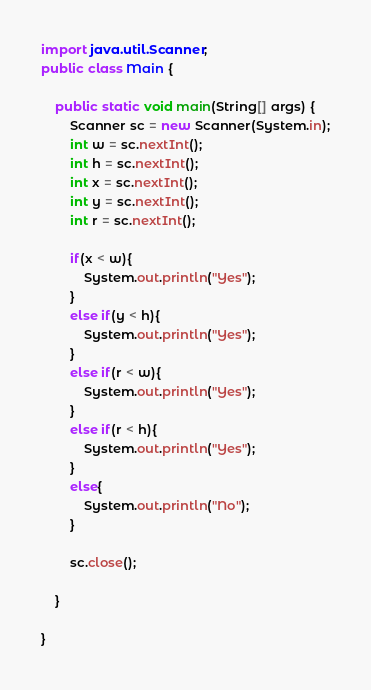<code> <loc_0><loc_0><loc_500><loc_500><_Java_>import java.util.Scanner;
public class Main {

	public static void main(String[] args) {
		Scanner sc = new Scanner(System.in);
		int w = sc.nextInt();
		int h = sc.nextInt();
		int x = sc.nextInt();
		int y = sc.nextInt();
		int r = sc.nextInt();

		if(x < w){
			System.out.println("Yes");
		}
		else if(y < h){
			System.out.println("Yes");
		}
		else if(r < w){
			System.out.println("Yes");
		}
		else if(r < h){
			System.out.println("Yes");
		}
		else{
			System.out.println("No");
		}
		
		sc.close();

	}

}</code> 